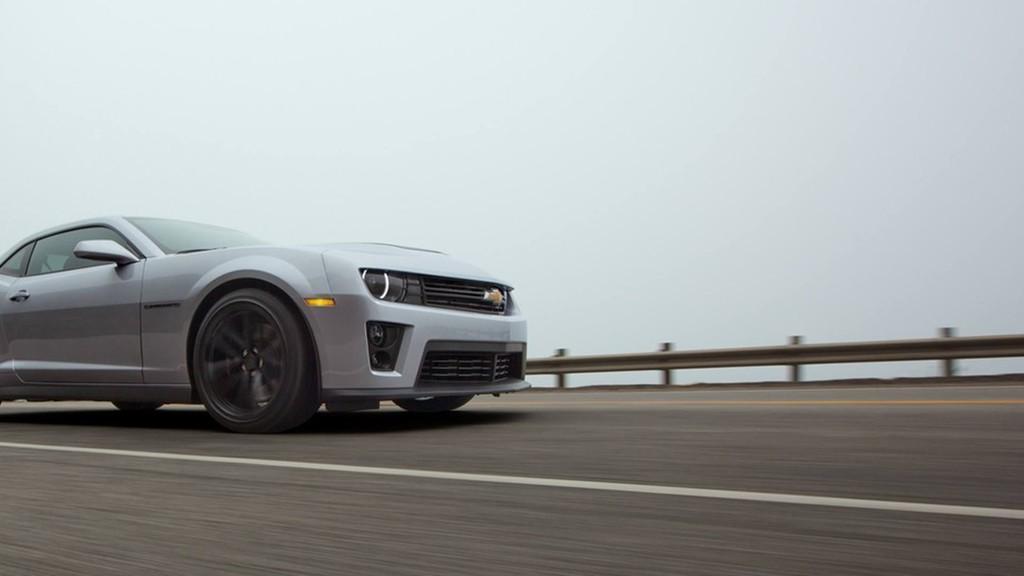Could you give a brief overview of what you see in this image? In this picture I can see a car on the road and I can see sky in the background. 